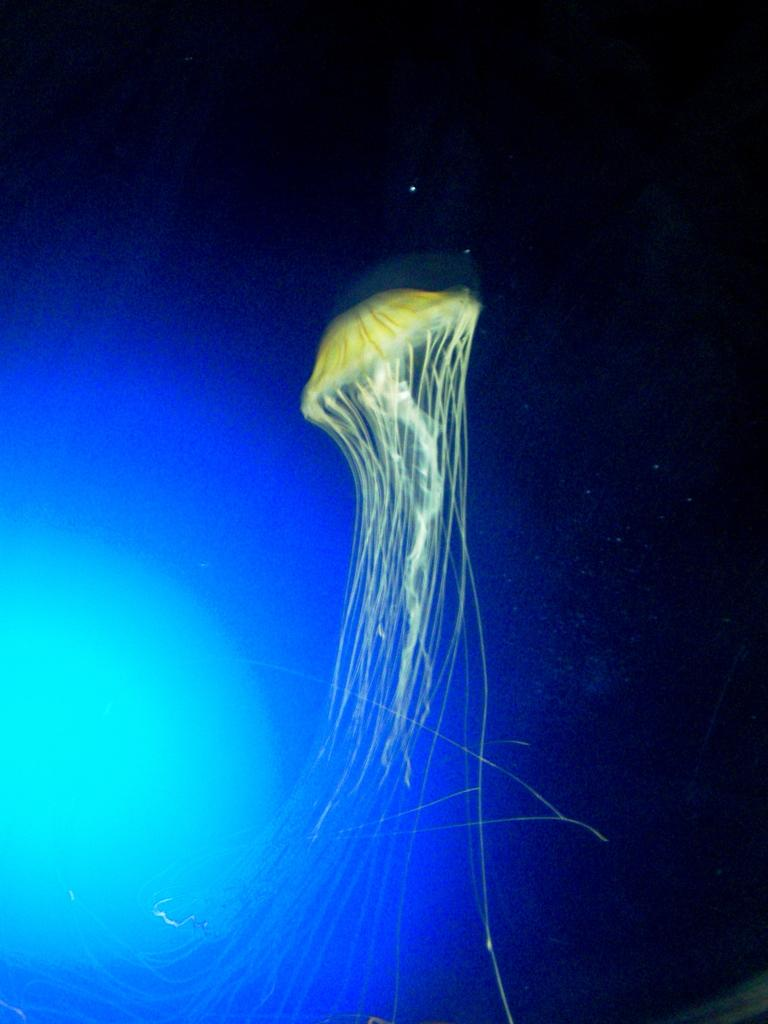What type of sea creature is in the image? There is a jellyfish in the image. What color is the jellyfish? The jellyfish is green in color. What can be seen on the left side of the image? There is a blue color light on the left side of the image. How would you describe the background of the image? The background of the image is dark. What type of jelly is being served during the harmony meal in the image? There is no jelly or meal present in the image; it features a green jellyfish and a blue color light. 